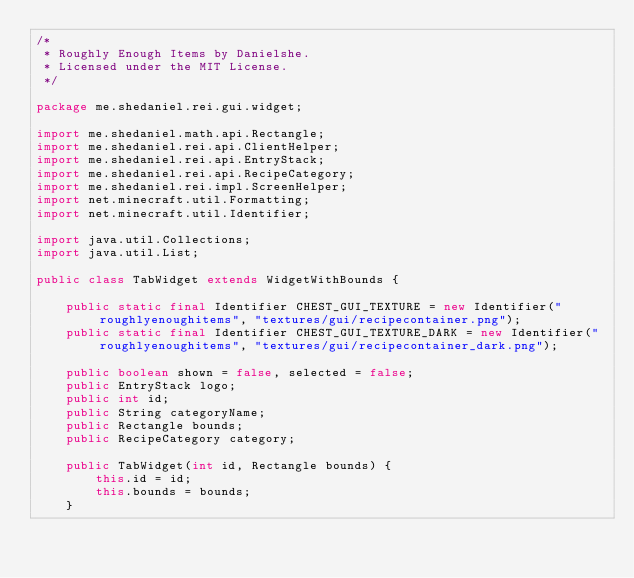Convert code to text. <code><loc_0><loc_0><loc_500><loc_500><_Java_>/*
 * Roughly Enough Items by Danielshe.
 * Licensed under the MIT License.
 */

package me.shedaniel.rei.gui.widget;

import me.shedaniel.math.api.Rectangle;
import me.shedaniel.rei.api.ClientHelper;
import me.shedaniel.rei.api.EntryStack;
import me.shedaniel.rei.api.RecipeCategory;
import me.shedaniel.rei.impl.ScreenHelper;
import net.minecraft.util.Formatting;
import net.minecraft.util.Identifier;

import java.util.Collections;
import java.util.List;

public class TabWidget extends WidgetWithBounds {

    public static final Identifier CHEST_GUI_TEXTURE = new Identifier("roughlyenoughitems", "textures/gui/recipecontainer.png");
    public static final Identifier CHEST_GUI_TEXTURE_DARK = new Identifier("roughlyenoughitems", "textures/gui/recipecontainer_dark.png");

    public boolean shown = false, selected = false;
    public EntryStack logo;
    public int id;
    public String categoryName;
    public Rectangle bounds;
    public RecipeCategory category;

    public TabWidget(int id, Rectangle bounds) {
        this.id = id;
        this.bounds = bounds;
    }
</code> 